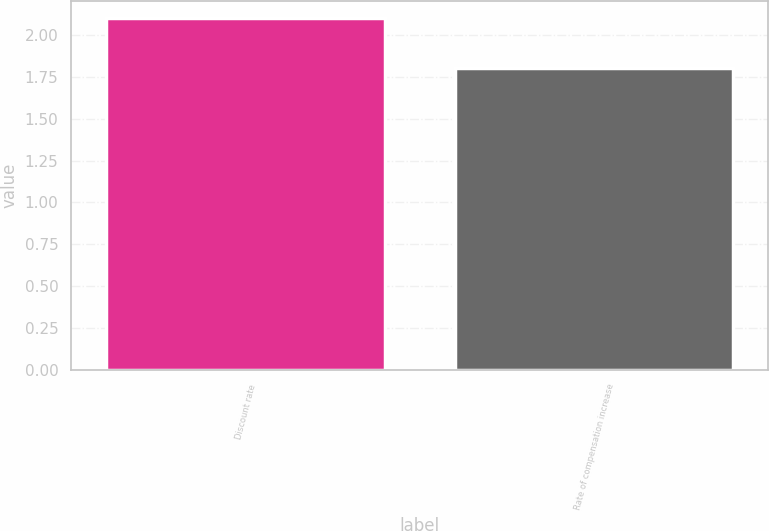Convert chart. <chart><loc_0><loc_0><loc_500><loc_500><bar_chart><fcel>Discount rate<fcel>Rate of compensation increase<nl><fcel>2.1<fcel>1.8<nl></chart> 